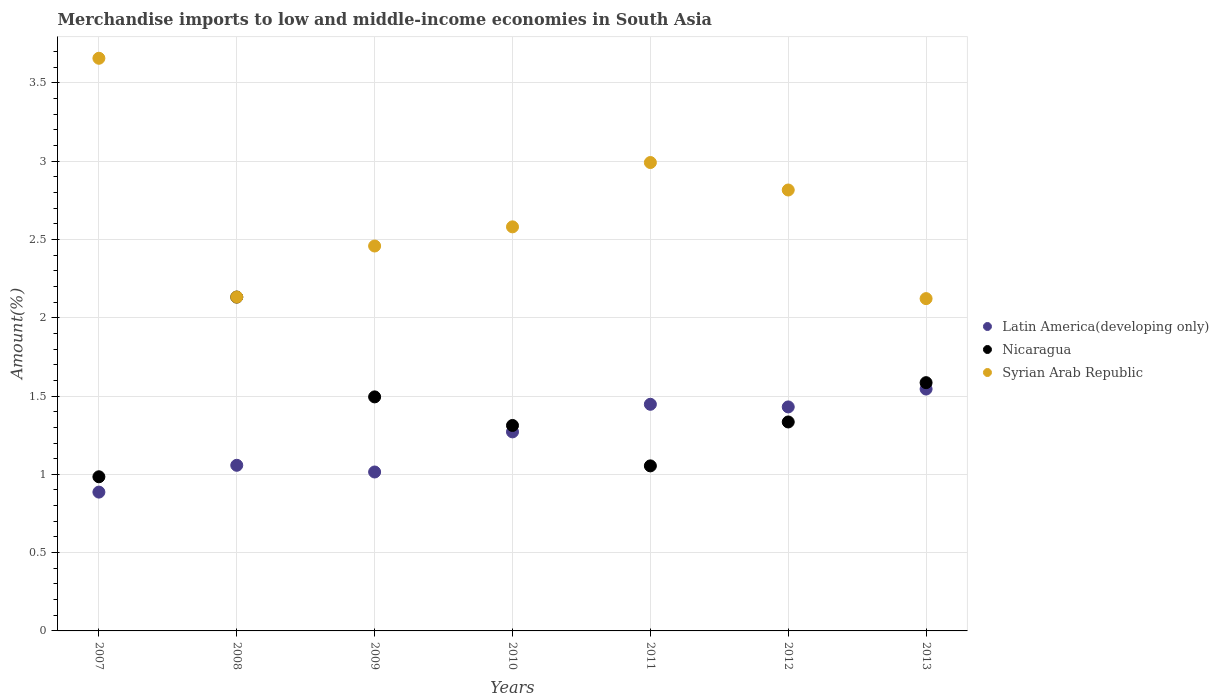How many different coloured dotlines are there?
Your answer should be very brief. 3. Is the number of dotlines equal to the number of legend labels?
Give a very brief answer. Yes. What is the percentage of amount earned from merchandise imports in Nicaragua in 2010?
Provide a succinct answer. 1.31. Across all years, what is the maximum percentage of amount earned from merchandise imports in Latin America(developing only)?
Offer a terse response. 1.54. Across all years, what is the minimum percentage of amount earned from merchandise imports in Syrian Arab Republic?
Your answer should be compact. 2.12. In which year was the percentage of amount earned from merchandise imports in Syrian Arab Republic maximum?
Offer a very short reply. 2007. In which year was the percentage of amount earned from merchandise imports in Syrian Arab Republic minimum?
Make the answer very short. 2013. What is the total percentage of amount earned from merchandise imports in Latin America(developing only) in the graph?
Keep it short and to the point. 8.65. What is the difference between the percentage of amount earned from merchandise imports in Syrian Arab Republic in 2007 and that in 2010?
Give a very brief answer. 1.08. What is the difference between the percentage of amount earned from merchandise imports in Nicaragua in 2009 and the percentage of amount earned from merchandise imports in Latin America(developing only) in 2010?
Provide a succinct answer. 0.22. What is the average percentage of amount earned from merchandise imports in Nicaragua per year?
Give a very brief answer. 1.41. In the year 2008, what is the difference between the percentage of amount earned from merchandise imports in Latin America(developing only) and percentage of amount earned from merchandise imports in Nicaragua?
Your response must be concise. -1.07. In how many years, is the percentage of amount earned from merchandise imports in Latin America(developing only) greater than 2.4 %?
Offer a terse response. 0. What is the ratio of the percentage of amount earned from merchandise imports in Syrian Arab Republic in 2008 to that in 2011?
Ensure brevity in your answer.  0.71. Is the difference between the percentage of amount earned from merchandise imports in Latin America(developing only) in 2007 and 2010 greater than the difference between the percentage of amount earned from merchandise imports in Nicaragua in 2007 and 2010?
Your answer should be compact. No. What is the difference between the highest and the second highest percentage of amount earned from merchandise imports in Latin America(developing only)?
Keep it short and to the point. 0.1. What is the difference between the highest and the lowest percentage of amount earned from merchandise imports in Nicaragua?
Provide a short and direct response. 1.15. Is the sum of the percentage of amount earned from merchandise imports in Syrian Arab Republic in 2007 and 2010 greater than the maximum percentage of amount earned from merchandise imports in Latin America(developing only) across all years?
Your response must be concise. Yes. How many years are there in the graph?
Offer a very short reply. 7. What is the difference between two consecutive major ticks on the Y-axis?
Your answer should be compact. 0.5. Are the values on the major ticks of Y-axis written in scientific E-notation?
Provide a short and direct response. No. Does the graph contain grids?
Ensure brevity in your answer.  Yes. How are the legend labels stacked?
Your answer should be compact. Vertical. What is the title of the graph?
Provide a succinct answer. Merchandise imports to low and middle-income economies in South Asia. What is the label or title of the X-axis?
Keep it short and to the point. Years. What is the label or title of the Y-axis?
Your answer should be compact. Amount(%). What is the Amount(%) of Latin America(developing only) in 2007?
Your response must be concise. 0.89. What is the Amount(%) of Nicaragua in 2007?
Your answer should be very brief. 0.98. What is the Amount(%) of Syrian Arab Republic in 2007?
Make the answer very short. 3.66. What is the Amount(%) in Latin America(developing only) in 2008?
Offer a very short reply. 1.06. What is the Amount(%) of Nicaragua in 2008?
Your answer should be very brief. 2.13. What is the Amount(%) in Syrian Arab Republic in 2008?
Give a very brief answer. 2.13. What is the Amount(%) of Latin America(developing only) in 2009?
Your answer should be very brief. 1.01. What is the Amount(%) of Nicaragua in 2009?
Your answer should be very brief. 1.49. What is the Amount(%) of Syrian Arab Republic in 2009?
Provide a short and direct response. 2.46. What is the Amount(%) in Latin America(developing only) in 2010?
Keep it short and to the point. 1.27. What is the Amount(%) of Nicaragua in 2010?
Your response must be concise. 1.31. What is the Amount(%) in Syrian Arab Republic in 2010?
Your answer should be very brief. 2.58. What is the Amount(%) of Latin America(developing only) in 2011?
Ensure brevity in your answer.  1.45. What is the Amount(%) in Nicaragua in 2011?
Your answer should be compact. 1.05. What is the Amount(%) of Syrian Arab Republic in 2011?
Make the answer very short. 2.99. What is the Amount(%) of Latin America(developing only) in 2012?
Give a very brief answer. 1.43. What is the Amount(%) of Nicaragua in 2012?
Provide a short and direct response. 1.33. What is the Amount(%) of Syrian Arab Republic in 2012?
Make the answer very short. 2.82. What is the Amount(%) of Latin America(developing only) in 2013?
Make the answer very short. 1.54. What is the Amount(%) of Nicaragua in 2013?
Offer a very short reply. 1.59. What is the Amount(%) in Syrian Arab Republic in 2013?
Give a very brief answer. 2.12. Across all years, what is the maximum Amount(%) in Latin America(developing only)?
Offer a terse response. 1.54. Across all years, what is the maximum Amount(%) in Nicaragua?
Offer a terse response. 2.13. Across all years, what is the maximum Amount(%) in Syrian Arab Republic?
Offer a very short reply. 3.66. Across all years, what is the minimum Amount(%) of Latin America(developing only)?
Your response must be concise. 0.89. Across all years, what is the minimum Amount(%) in Nicaragua?
Your answer should be very brief. 0.98. Across all years, what is the minimum Amount(%) in Syrian Arab Republic?
Your answer should be very brief. 2.12. What is the total Amount(%) of Latin America(developing only) in the graph?
Your response must be concise. 8.65. What is the total Amount(%) of Nicaragua in the graph?
Give a very brief answer. 9.9. What is the total Amount(%) of Syrian Arab Republic in the graph?
Ensure brevity in your answer.  18.76. What is the difference between the Amount(%) in Latin America(developing only) in 2007 and that in 2008?
Make the answer very short. -0.17. What is the difference between the Amount(%) in Nicaragua in 2007 and that in 2008?
Offer a terse response. -1.15. What is the difference between the Amount(%) of Syrian Arab Republic in 2007 and that in 2008?
Your answer should be compact. 1.52. What is the difference between the Amount(%) of Latin America(developing only) in 2007 and that in 2009?
Ensure brevity in your answer.  -0.13. What is the difference between the Amount(%) of Nicaragua in 2007 and that in 2009?
Keep it short and to the point. -0.51. What is the difference between the Amount(%) in Syrian Arab Republic in 2007 and that in 2009?
Your answer should be very brief. 1.2. What is the difference between the Amount(%) in Latin America(developing only) in 2007 and that in 2010?
Ensure brevity in your answer.  -0.38. What is the difference between the Amount(%) of Nicaragua in 2007 and that in 2010?
Offer a terse response. -0.33. What is the difference between the Amount(%) of Syrian Arab Republic in 2007 and that in 2010?
Your answer should be very brief. 1.08. What is the difference between the Amount(%) in Latin America(developing only) in 2007 and that in 2011?
Give a very brief answer. -0.56. What is the difference between the Amount(%) of Nicaragua in 2007 and that in 2011?
Your response must be concise. -0.07. What is the difference between the Amount(%) of Syrian Arab Republic in 2007 and that in 2011?
Make the answer very short. 0.67. What is the difference between the Amount(%) in Latin America(developing only) in 2007 and that in 2012?
Your response must be concise. -0.54. What is the difference between the Amount(%) of Nicaragua in 2007 and that in 2012?
Keep it short and to the point. -0.35. What is the difference between the Amount(%) of Syrian Arab Republic in 2007 and that in 2012?
Your response must be concise. 0.84. What is the difference between the Amount(%) in Latin America(developing only) in 2007 and that in 2013?
Ensure brevity in your answer.  -0.66. What is the difference between the Amount(%) in Nicaragua in 2007 and that in 2013?
Keep it short and to the point. -0.6. What is the difference between the Amount(%) in Syrian Arab Republic in 2007 and that in 2013?
Provide a short and direct response. 1.53. What is the difference between the Amount(%) of Latin America(developing only) in 2008 and that in 2009?
Offer a terse response. 0.04. What is the difference between the Amount(%) of Nicaragua in 2008 and that in 2009?
Offer a terse response. 0.64. What is the difference between the Amount(%) of Syrian Arab Republic in 2008 and that in 2009?
Ensure brevity in your answer.  -0.33. What is the difference between the Amount(%) in Latin America(developing only) in 2008 and that in 2010?
Offer a terse response. -0.21. What is the difference between the Amount(%) in Nicaragua in 2008 and that in 2010?
Your answer should be compact. 0.82. What is the difference between the Amount(%) in Syrian Arab Republic in 2008 and that in 2010?
Give a very brief answer. -0.45. What is the difference between the Amount(%) of Latin America(developing only) in 2008 and that in 2011?
Make the answer very short. -0.39. What is the difference between the Amount(%) in Nicaragua in 2008 and that in 2011?
Provide a short and direct response. 1.08. What is the difference between the Amount(%) in Syrian Arab Republic in 2008 and that in 2011?
Ensure brevity in your answer.  -0.86. What is the difference between the Amount(%) in Latin America(developing only) in 2008 and that in 2012?
Give a very brief answer. -0.37. What is the difference between the Amount(%) of Nicaragua in 2008 and that in 2012?
Provide a succinct answer. 0.8. What is the difference between the Amount(%) of Syrian Arab Republic in 2008 and that in 2012?
Offer a terse response. -0.68. What is the difference between the Amount(%) of Latin America(developing only) in 2008 and that in 2013?
Your answer should be very brief. -0.49. What is the difference between the Amount(%) in Nicaragua in 2008 and that in 2013?
Offer a terse response. 0.55. What is the difference between the Amount(%) in Syrian Arab Republic in 2008 and that in 2013?
Keep it short and to the point. 0.01. What is the difference between the Amount(%) in Latin America(developing only) in 2009 and that in 2010?
Offer a terse response. -0.26. What is the difference between the Amount(%) of Nicaragua in 2009 and that in 2010?
Provide a succinct answer. 0.18. What is the difference between the Amount(%) of Syrian Arab Republic in 2009 and that in 2010?
Make the answer very short. -0.12. What is the difference between the Amount(%) in Latin America(developing only) in 2009 and that in 2011?
Provide a succinct answer. -0.43. What is the difference between the Amount(%) of Nicaragua in 2009 and that in 2011?
Offer a terse response. 0.44. What is the difference between the Amount(%) of Syrian Arab Republic in 2009 and that in 2011?
Ensure brevity in your answer.  -0.53. What is the difference between the Amount(%) in Latin America(developing only) in 2009 and that in 2012?
Give a very brief answer. -0.42. What is the difference between the Amount(%) of Nicaragua in 2009 and that in 2012?
Your response must be concise. 0.16. What is the difference between the Amount(%) of Syrian Arab Republic in 2009 and that in 2012?
Your answer should be compact. -0.36. What is the difference between the Amount(%) of Latin America(developing only) in 2009 and that in 2013?
Offer a very short reply. -0.53. What is the difference between the Amount(%) in Nicaragua in 2009 and that in 2013?
Make the answer very short. -0.09. What is the difference between the Amount(%) of Syrian Arab Republic in 2009 and that in 2013?
Your response must be concise. 0.34. What is the difference between the Amount(%) of Latin America(developing only) in 2010 and that in 2011?
Your answer should be very brief. -0.18. What is the difference between the Amount(%) in Nicaragua in 2010 and that in 2011?
Provide a succinct answer. 0.26. What is the difference between the Amount(%) of Syrian Arab Republic in 2010 and that in 2011?
Offer a terse response. -0.41. What is the difference between the Amount(%) of Latin America(developing only) in 2010 and that in 2012?
Offer a terse response. -0.16. What is the difference between the Amount(%) of Nicaragua in 2010 and that in 2012?
Your response must be concise. -0.02. What is the difference between the Amount(%) of Syrian Arab Republic in 2010 and that in 2012?
Make the answer very short. -0.24. What is the difference between the Amount(%) of Latin America(developing only) in 2010 and that in 2013?
Provide a short and direct response. -0.27. What is the difference between the Amount(%) in Nicaragua in 2010 and that in 2013?
Your response must be concise. -0.27. What is the difference between the Amount(%) of Syrian Arab Republic in 2010 and that in 2013?
Ensure brevity in your answer.  0.46. What is the difference between the Amount(%) in Latin America(developing only) in 2011 and that in 2012?
Your answer should be very brief. 0.02. What is the difference between the Amount(%) of Nicaragua in 2011 and that in 2012?
Offer a terse response. -0.28. What is the difference between the Amount(%) of Syrian Arab Republic in 2011 and that in 2012?
Keep it short and to the point. 0.18. What is the difference between the Amount(%) of Latin America(developing only) in 2011 and that in 2013?
Give a very brief answer. -0.1. What is the difference between the Amount(%) in Nicaragua in 2011 and that in 2013?
Make the answer very short. -0.53. What is the difference between the Amount(%) in Syrian Arab Republic in 2011 and that in 2013?
Provide a short and direct response. 0.87. What is the difference between the Amount(%) of Latin America(developing only) in 2012 and that in 2013?
Your answer should be very brief. -0.11. What is the difference between the Amount(%) in Nicaragua in 2012 and that in 2013?
Keep it short and to the point. -0.25. What is the difference between the Amount(%) in Syrian Arab Republic in 2012 and that in 2013?
Offer a terse response. 0.69. What is the difference between the Amount(%) of Latin America(developing only) in 2007 and the Amount(%) of Nicaragua in 2008?
Your answer should be very brief. -1.25. What is the difference between the Amount(%) in Latin America(developing only) in 2007 and the Amount(%) in Syrian Arab Republic in 2008?
Keep it short and to the point. -1.25. What is the difference between the Amount(%) in Nicaragua in 2007 and the Amount(%) in Syrian Arab Republic in 2008?
Offer a very short reply. -1.15. What is the difference between the Amount(%) of Latin America(developing only) in 2007 and the Amount(%) of Nicaragua in 2009?
Your answer should be compact. -0.61. What is the difference between the Amount(%) of Latin America(developing only) in 2007 and the Amount(%) of Syrian Arab Republic in 2009?
Keep it short and to the point. -1.57. What is the difference between the Amount(%) of Nicaragua in 2007 and the Amount(%) of Syrian Arab Republic in 2009?
Ensure brevity in your answer.  -1.47. What is the difference between the Amount(%) in Latin America(developing only) in 2007 and the Amount(%) in Nicaragua in 2010?
Your answer should be very brief. -0.43. What is the difference between the Amount(%) in Latin America(developing only) in 2007 and the Amount(%) in Syrian Arab Republic in 2010?
Provide a short and direct response. -1.69. What is the difference between the Amount(%) in Nicaragua in 2007 and the Amount(%) in Syrian Arab Republic in 2010?
Your answer should be very brief. -1.6. What is the difference between the Amount(%) of Latin America(developing only) in 2007 and the Amount(%) of Nicaragua in 2011?
Offer a terse response. -0.17. What is the difference between the Amount(%) of Latin America(developing only) in 2007 and the Amount(%) of Syrian Arab Republic in 2011?
Give a very brief answer. -2.1. What is the difference between the Amount(%) of Nicaragua in 2007 and the Amount(%) of Syrian Arab Republic in 2011?
Keep it short and to the point. -2.01. What is the difference between the Amount(%) in Latin America(developing only) in 2007 and the Amount(%) in Nicaragua in 2012?
Make the answer very short. -0.45. What is the difference between the Amount(%) in Latin America(developing only) in 2007 and the Amount(%) in Syrian Arab Republic in 2012?
Your response must be concise. -1.93. What is the difference between the Amount(%) of Nicaragua in 2007 and the Amount(%) of Syrian Arab Republic in 2012?
Provide a short and direct response. -1.83. What is the difference between the Amount(%) in Latin America(developing only) in 2007 and the Amount(%) in Nicaragua in 2013?
Your answer should be compact. -0.7. What is the difference between the Amount(%) in Latin America(developing only) in 2007 and the Amount(%) in Syrian Arab Republic in 2013?
Give a very brief answer. -1.24. What is the difference between the Amount(%) of Nicaragua in 2007 and the Amount(%) of Syrian Arab Republic in 2013?
Offer a very short reply. -1.14. What is the difference between the Amount(%) of Latin America(developing only) in 2008 and the Amount(%) of Nicaragua in 2009?
Provide a short and direct response. -0.44. What is the difference between the Amount(%) of Latin America(developing only) in 2008 and the Amount(%) of Syrian Arab Republic in 2009?
Your answer should be compact. -1.4. What is the difference between the Amount(%) in Nicaragua in 2008 and the Amount(%) in Syrian Arab Republic in 2009?
Provide a succinct answer. -0.33. What is the difference between the Amount(%) of Latin America(developing only) in 2008 and the Amount(%) of Nicaragua in 2010?
Offer a very short reply. -0.25. What is the difference between the Amount(%) of Latin America(developing only) in 2008 and the Amount(%) of Syrian Arab Republic in 2010?
Your answer should be compact. -1.52. What is the difference between the Amount(%) of Nicaragua in 2008 and the Amount(%) of Syrian Arab Republic in 2010?
Offer a very short reply. -0.45. What is the difference between the Amount(%) in Latin America(developing only) in 2008 and the Amount(%) in Nicaragua in 2011?
Offer a very short reply. 0. What is the difference between the Amount(%) in Latin America(developing only) in 2008 and the Amount(%) in Syrian Arab Republic in 2011?
Ensure brevity in your answer.  -1.93. What is the difference between the Amount(%) in Nicaragua in 2008 and the Amount(%) in Syrian Arab Republic in 2011?
Provide a short and direct response. -0.86. What is the difference between the Amount(%) in Latin America(developing only) in 2008 and the Amount(%) in Nicaragua in 2012?
Offer a very short reply. -0.28. What is the difference between the Amount(%) in Latin America(developing only) in 2008 and the Amount(%) in Syrian Arab Republic in 2012?
Offer a very short reply. -1.76. What is the difference between the Amount(%) of Nicaragua in 2008 and the Amount(%) of Syrian Arab Republic in 2012?
Ensure brevity in your answer.  -0.68. What is the difference between the Amount(%) of Latin America(developing only) in 2008 and the Amount(%) of Nicaragua in 2013?
Make the answer very short. -0.53. What is the difference between the Amount(%) of Latin America(developing only) in 2008 and the Amount(%) of Syrian Arab Republic in 2013?
Give a very brief answer. -1.06. What is the difference between the Amount(%) in Nicaragua in 2008 and the Amount(%) in Syrian Arab Republic in 2013?
Your response must be concise. 0.01. What is the difference between the Amount(%) in Latin America(developing only) in 2009 and the Amount(%) in Nicaragua in 2010?
Offer a terse response. -0.3. What is the difference between the Amount(%) in Latin America(developing only) in 2009 and the Amount(%) in Syrian Arab Republic in 2010?
Give a very brief answer. -1.57. What is the difference between the Amount(%) of Nicaragua in 2009 and the Amount(%) of Syrian Arab Republic in 2010?
Your answer should be compact. -1.09. What is the difference between the Amount(%) in Latin America(developing only) in 2009 and the Amount(%) in Nicaragua in 2011?
Keep it short and to the point. -0.04. What is the difference between the Amount(%) of Latin America(developing only) in 2009 and the Amount(%) of Syrian Arab Republic in 2011?
Your answer should be very brief. -1.98. What is the difference between the Amount(%) of Nicaragua in 2009 and the Amount(%) of Syrian Arab Republic in 2011?
Your response must be concise. -1.5. What is the difference between the Amount(%) of Latin America(developing only) in 2009 and the Amount(%) of Nicaragua in 2012?
Offer a terse response. -0.32. What is the difference between the Amount(%) in Latin America(developing only) in 2009 and the Amount(%) in Syrian Arab Republic in 2012?
Make the answer very short. -1.8. What is the difference between the Amount(%) of Nicaragua in 2009 and the Amount(%) of Syrian Arab Republic in 2012?
Your answer should be very brief. -1.32. What is the difference between the Amount(%) in Latin America(developing only) in 2009 and the Amount(%) in Nicaragua in 2013?
Give a very brief answer. -0.57. What is the difference between the Amount(%) of Latin America(developing only) in 2009 and the Amount(%) of Syrian Arab Republic in 2013?
Provide a short and direct response. -1.11. What is the difference between the Amount(%) in Nicaragua in 2009 and the Amount(%) in Syrian Arab Republic in 2013?
Your answer should be compact. -0.63. What is the difference between the Amount(%) of Latin America(developing only) in 2010 and the Amount(%) of Nicaragua in 2011?
Provide a short and direct response. 0.22. What is the difference between the Amount(%) of Latin America(developing only) in 2010 and the Amount(%) of Syrian Arab Republic in 2011?
Provide a succinct answer. -1.72. What is the difference between the Amount(%) of Nicaragua in 2010 and the Amount(%) of Syrian Arab Republic in 2011?
Your answer should be very brief. -1.68. What is the difference between the Amount(%) of Latin America(developing only) in 2010 and the Amount(%) of Nicaragua in 2012?
Offer a terse response. -0.06. What is the difference between the Amount(%) in Latin America(developing only) in 2010 and the Amount(%) in Syrian Arab Republic in 2012?
Provide a succinct answer. -1.54. What is the difference between the Amount(%) of Nicaragua in 2010 and the Amount(%) of Syrian Arab Republic in 2012?
Provide a short and direct response. -1.5. What is the difference between the Amount(%) of Latin America(developing only) in 2010 and the Amount(%) of Nicaragua in 2013?
Offer a very short reply. -0.31. What is the difference between the Amount(%) in Latin America(developing only) in 2010 and the Amount(%) in Syrian Arab Republic in 2013?
Make the answer very short. -0.85. What is the difference between the Amount(%) in Nicaragua in 2010 and the Amount(%) in Syrian Arab Republic in 2013?
Your answer should be compact. -0.81. What is the difference between the Amount(%) in Latin America(developing only) in 2011 and the Amount(%) in Nicaragua in 2012?
Ensure brevity in your answer.  0.11. What is the difference between the Amount(%) in Latin America(developing only) in 2011 and the Amount(%) in Syrian Arab Republic in 2012?
Give a very brief answer. -1.37. What is the difference between the Amount(%) of Nicaragua in 2011 and the Amount(%) of Syrian Arab Republic in 2012?
Your answer should be very brief. -1.76. What is the difference between the Amount(%) in Latin America(developing only) in 2011 and the Amount(%) in Nicaragua in 2013?
Offer a terse response. -0.14. What is the difference between the Amount(%) in Latin America(developing only) in 2011 and the Amount(%) in Syrian Arab Republic in 2013?
Offer a very short reply. -0.67. What is the difference between the Amount(%) in Nicaragua in 2011 and the Amount(%) in Syrian Arab Republic in 2013?
Offer a terse response. -1.07. What is the difference between the Amount(%) in Latin America(developing only) in 2012 and the Amount(%) in Nicaragua in 2013?
Offer a terse response. -0.15. What is the difference between the Amount(%) in Latin America(developing only) in 2012 and the Amount(%) in Syrian Arab Republic in 2013?
Keep it short and to the point. -0.69. What is the difference between the Amount(%) of Nicaragua in 2012 and the Amount(%) of Syrian Arab Republic in 2013?
Your answer should be compact. -0.79. What is the average Amount(%) of Latin America(developing only) per year?
Give a very brief answer. 1.24. What is the average Amount(%) of Nicaragua per year?
Offer a very short reply. 1.41. What is the average Amount(%) of Syrian Arab Republic per year?
Your response must be concise. 2.68. In the year 2007, what is the difference between the Amount(%) of Latin America(developing only) and Amount(%) of Nicaragua?
Provide a short and direct response. -0.1. In the year 2007, what is the difference between the Amount(%) in Latin America(developing only) and Amount(%) in Syrian Arab Republic?
Make the answer very short. -2.77. In the year 2007, what is the difference between the Amount(%) in Nicaragua and Amount(%) in Syrian Arab Republic?
Make the answer very short. -2.67. In the year 2008, what is the difference between the Amount(%) in Latin America(developing only) and Amount(%) in Nicaragua?
Provide a succinct answer. -1.07. In the year 2008, what is the difference between the Amount(%) of Latin America(developing only) and Amount(%) of Syrian Arab Republic?
Make the answer very short. -1.07. In the year 2008, what is the difference between the Amount(%) in Nicaragua and Amount(%) in Syrian Arab Republic?
Make the answer very short. -0. In the year 2009, what is the difference between the Amount(%) of Latin America(developing only) and Amount(%) of Nicaragua?
Offer a very short reply. -0.48. In the year 2009, what is the difference between the Amount(%) in Latin America(developing only) and Amount(%) in Syrian Arab Republic?
Give a very brief answer. -1.44. In the year 2009, what is the difference between the Amount(%) in Nicaragua and Amount(%) in Syrian Arab Republic?
Your response must be concise. -0.96. In the year 2010, what is the difference between the Amount(%) in Latin America(developing only) and Amount(%) in Nicaragua?
Your response must be concise. -0.04. In the year 2010, what is the difference between the Amount(%) in Latin America(developing only) and Amount(%) in Syrian Arab Republic?
Offer a terse response. -1.31. In the year 2010, what is the difference between the Amount(%) of Nicaragua and Amount(%) of Syrian Arab Republic?
Ensure brevity in your answer.  -1.27. In the year 2011, what is the difference between the Amount(%) in Latin America(developing only) and Amount(%) in Nicaragua?
Your answer should be very brief. 0.39. In the year 2011, what is the difference between the Amount(%) of Latin America(developing only) and Amount(%) of Syrian Arab Republic?
Make the answer very short. -1.54. In the year 2011, what is the difference between the Amount(%) in Nicaragua and Amount(%) in Syrian Arab Republic?
Ensure brevity in your answer.  -1.94. In the year 2012, what is the difference between the Amount(%) in Latin America(developing only) and Amount(%) in Nicaragua?
Offer a terse response. 0.1. In the year 2012, what is the difference between the Amount(%) in Latin America(developing only) and Amount(%) in Syrian Arab Republic?
Keep it short and to the point. -1.39. In the year 2012, what is the difference between the Amount(%) of Nicaragua and Amount(%) of Syrian Arab Republic?
Offer a terse response. -1.48. In the year 2013, what is the difference between the Amount(%) in Latin America(developing only) and Amount(%) in Nicaragua?
Your answer should be very brief. -0.04. In the year 2013, what is the difference between the Amount(%) in Latin America(developing only) and Amount(%) in Syrian Arab Republic?
Offer a very short reply. -0.58. In the year 2013, what is the difference between the Amount(%) in Nicaragua and Amount(%) in Syrian Arab Republic?
Make the answer very short. -0.54. What is the ratio of the Amount(%) in Latin America(developing only) in 2007 to that in 2008?
Keep it short and to the point. 0.84. What is the ratio of the Amount(%) of Nicaragua in 2007 to that in 2008?
Ensure brevity in your answer.  0.46. What is the ratio of the Amount(%) of Syrian Arab Republic in 2007 to that in 2008?
Keep it short and to the point. 1.72. What is the ratio of the Amount(%) in Latin America(developing only) in 2007 to that in 2009?
Provide a succinct answer. 0.87. What is the ratio of the Amount(%) of Nicaragua in 2007 to that in 2009?
Keep it short and to the point. 0.66. What is the ratio of the Amount(%) in Syrian Arab Republic in 2007 to that in 2009?
Keep it short and to the point. 1.49. What is the ratio of the Amount(%) in Latin America(developing only) in 2007 to that in 2010?
Provide a succinct answer. 0.7. What is the ratio of the Amount(%) in Nicaragua in 2007 to that in 2010?
Ensure brevity in your answer.  0.75. What is the ratio of the Amount(%) of Syrian Arab Republic in 2007 to that in 2010?
Provide a short and direct response. 1.42. What is the ratio of the Amount(%) in Latin America(developing only) in 2007 to that in 2011?
Provide a short and direct response. 0.61. What is the ratio of the Amount(%) in Nicaragua in 2007 to that in 2011?
Make the answer very short. 0.93. What is the ratio of the Amount(%) in Syrian Arab Republic in 2007 to that in 2011?
Ensure brevity in your answer.  1.22. What is the ratio of the Amount(%) in Latin America(developing only) in 2007 to that in 2012?
Offer a terse response. 0.62. What is the ratio of the Amount(%) of Nicaragua in 2007 to that in 2012?
Provide a succinct answer. 0.74. What is the ratio of the Amount(%) in Syrian Arab Republic in 2007 to that in 2012?
Ensure brevity in your answer.  1.3. What is the ratio of the Amount(%) in Latin America(developing only) in 2007 to that in 2013?
Ensure brevity in your answer.  0.57. What is the ratio of the Amount(%) of Nicaragua in 2007 to that in 2013?
Provide a succinct answer. 0.62. What is the ratio of the Amount(%) of Syrian Arab Republic in 2007 to that in 2013?
Provide a succinct answer. 1.72. What is the ratio of the Amount(%) in Latin America(developing only) in 2008 to that in 2009?
Give a very brief answer. 1.04. What is the ratio of the Amount(%) of Nicaragua in 2008 to that in 2009?
Offer a terse response. 1.43. What is the ratio of the Amount(%) of Syrian Arab Republic in 2008 to that in 2009?
Provide a succinct answer. 0.87. What is the ratio of the Amount(%) of Latin America(developing only) in 2008 to that in 2010?
Give a very brief answer. 0.83. What is the ratio of the Amount(%) of Nicaragua in 2008 to that in 2010?
Provide a short and direct response. 1.62. What is the ratio of the Amount(%) of Syrian Arab Republic in 2008 to that in 2010?
Offer a terse response. 0.83. What is the ratio of the Amount(%) in Latin America(developing only) in 2008 to that in 2011?
Your response must be concise. 0.73. What is the ratio of the Amount(%) of Nicaragua in 2008 to that in 2011?
Provide a short and direct response. 2.02. What is the ratio of the Amount(%) of Syrian Arab Republic in 2008 to that in 2011?
Offer a terse response. 0.71. What is the ratio of the Amount(%) of Latin America(developing only) in 2008 to that in 2012?
Give a very brief answer. 0.74. What is the ratio of the Amount(%) of Nicaragua in 2008 to that in 2012?
Your answer should be compact. 1.6. What is the ratio of the Amount(%) of Syrian Arab Republic in 2008 to that in 2012?
Offer a terse response. 0.76. What is the ratio of the Amount(%) in Latin America(developing only) in 2008 to that in 2013?
Ensure brevity in your answer.  0.68. What is the ratio of the Amount(%) in Nicaragua in 2008 to that in 2013?
Make the answer very short. 1.34. What is the ratio of the Amount(%) of Syrian Arab Republic in 2008 to that in 2013?
Offer a terse response. 1. What is the ratio of the Amount(%) in Latin America(developing only) in 2009 to that in 2010?
Provide a succinct answer. 0.8. What is the ratio of the Amount(%) of Nicaragua in 2009 to that in 2010?
Make the answer very short. 1.14. What is the ratio of the Amount(%) of Syrian Arab Republic in 2009 to that in 2010?
Make the answer very short. 0.95. What is the ratio of the Amount(%) in Latin America(developing only) in 2009 to that in 2011?
Offer a terse response. 0.7. What is the ratio of the Amount(%) in Nicaragua in 2009 to that in 2011?
Provide a succinct answer. 1.42. What is the ratio of the Amount(%) in Syrian Arab Republic in 2009 to that in 2011?
Your answer should be very brief. 0.82. What is the ratio of the Amount(%) of Latin America(developing only) in 2009 to that in 2012?
Your response must be concise. 0.71. What is the ratio of the Amount(%) in Nicaragua in 2009 to that in 2012?
Give a very brief answer. 1.12. What is the ratio of the Amount(%) of Syrian Arab Republic in 2009 to that in 2012?
Provide a short and direct response. 0.87. What is the ratio of the Amount(%) in Latin America(developing only) in 2009 to that in 2013?
Offer a terse response. 0.66. What is the ratio of the Amount(%) in Nicaragua in 2009 to that in 2013?
Ensure brevity in your answer.  0.94. What is the ratio of the Amount(%) in Syrian Arab Republic in 2009 to that in 2013?
Your answer should be very brief. 1.16. What is the ratio of the Amount(%) of Latin America(developing only) in 2010 to that in 2011?
Keep it short and to the point. 0.88. What is the ratio of the Amount(%) in Nicaragua in 2010 to that in 2011?
Your answer should be compact. 1.24. What is the ratio of the Amount(%) of Syrian Arab Republic in 2010 to that in 2011?
Your answer should be very brief. 0.86. What is the ratio of the Amount(%) of Latin America(developing only) in 2010 to that in 2012?
Keep it short and to the point. 0.89. What is the ratio of the Amount(%) in Nicaragua in 2010 to that in 2012?
Make the answer very short. 0.98. What is the ratio of the Amount(%) in Syrian Arab Republic in 2010 to that in 2012?
Make the answer very short. 0.92. What is the ratio of the Amount(%) in Latin America(developing only) in 2010 to that in 2013?
Your answer should be very brief. 0.82. What is the ratio of the Amount(%) of Nicaragua in 2010 to that in 2013?
Provide a succinct answer. 0.83. What is the ratio of the Amount(%) of Syrian Arab Republic in 2010 to that in 2013?
Keep it short and to the point. 1.22. What is the ratio of the Amount(%) in Latin America(developing only) in 2011 to that in 2012?
Make the answer very short. 1.01. What is the ratio of the Amount(%) in Nicaragua in 2011 to that in 2012?
Your response must be concise. 0.79. What is the ratio of the Amount(%) of Syrian Arab Republic in 2011 to that in 2012?
Your answer should be compact. 1.06. What is the ratio of the Amount(%) in Latin America(developing only) in 2011 to that in 2013?
Offer a very short reply. 0.94. What is the ratio of the Amount(%) of Nicaragua in 2011 to that in 2013?
Your answer should be compact. 0.66. What is the ratio of the Amount(%) in Syrian Arab Republic in 2011 to that in 2013?
Ensure brevity in your answer.  1.41. What is the ratio of the Amount(%) in Latin America(developing only) in 2012 to that in 2013?
Offer a terse response. 0.93. What is the ratio of the Amount(%) of Nicaragua in 2012 to that in 2013?
Your response must be concise. 0.84. What is the ratio of the Amount(%) in Syrian Arab Republic in 2012 to that in 2013?
Your answer should be very brief. 1.33. What is the difference between the highest and the second highest Amount(%) of Latin America(developing only)?
Offer a very short reply. 0.1. What is the difference between the highest and the second highest Amount(%) in Nicaragua?
Make the answer very short. 0.55. What is the difference between the highest and the second highest Amount(%) of Syrian Arab Republic?
Your response must be concise. 0.67. What is the difference between the highest and the lowest Amount(%) in Latin America(developing only)?
Offer a terse response. 0.66. What is the difference between the highest and the lowest Amount(%) in Nicaragua?
Keep it short and to the point. 1.15. What is the difference between the highest and the lowest Amount(%) of Syrian Arab Republic?
Your answer should be compact. 1.53. 